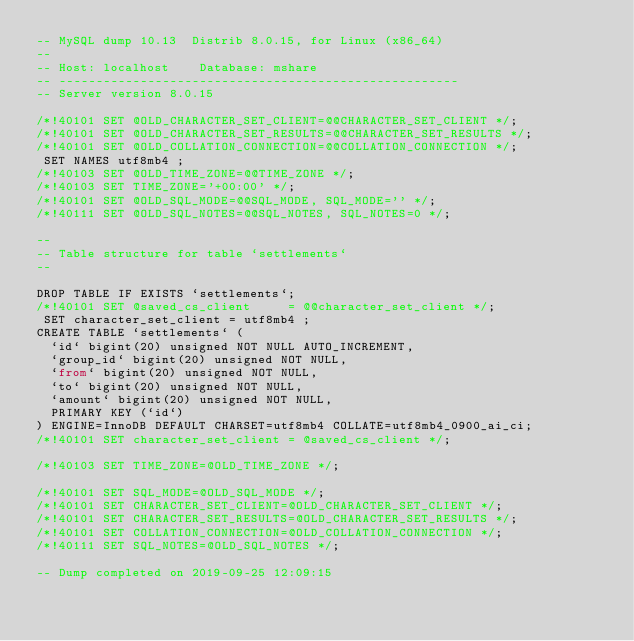Convert code to text. <code><loc_0><loc_0><loc_500><loc_500><_SQL_>-- MySQL dump 10.13  Distrib 8.0.15, for Linux (x86_64)
--
-- Host: localhost    Database: mshare
-- ------------------------------------------------------
-- Server version	8.0.15

/*!40101 SET @OLD_CHARACTER_SET_CLIENT=@@CHARACTER_SET_CLIENT */;
/*!40101 SET @OLD_CHARACTER_SET_RESULTS=@@CHARACTER_SET_RESULTS */;
/*!40101 SET @OLD_COLLATION_CONNECTION=@@COLLATION_CONNECTION */;
 SET NAMES utf8mb4 ;
/*!40103 SET @OLD_TIME_ZONE=@@TIME_ZONE */;
/*!40103 SET TIME_ZONE='+00:00' */;
/*!40101 SET @OLD_SQL_MODE=@@SQL_MODE, SQL_MODE='' */;
/*!40111 SET @OLD_SQL_NOTES=@@SQL_NOTES, SQL_NOTES=0 */;

--
-- Table structure for table `settlements`
--

DROP TABLE IF EXISTS `settlements`;
/*!40101 SET @saved_cs_client     = @@character_set_client */;
 SET character_set_client = utf8mb4 ;
CREATE TABLE `settlements` (
  `id` bigint(20) unsigned NOT NULL AUTO_INCREMENT,
  `group_id` bigint(20) unsigned NOT NULL,
  `from` bigint(20) unsigned NOT NULL,
  `to` bigint(20) unsigned NOT NULL,
  `amount` bigint(20) unsigned NOT NULL,
  PRIMARY KEY (`id`)
) ENGINE=InnoDB DEFAULT CHARSET=utf8mb4 COLLATE=utf8mb4_0900_ai_ci;
/*!40101 SET character_set_client = @saved_cs_client */;

/*!40103 SET TIME_ZONE=@OLD_TIME_ZONE */;

/*!40101 SET SQL_MODE=@OLD_SQL_MODE */;
/*!40101 SET CHARACTER_SET_CLIENT=@OLD_CHARACTER_SET_CLIENT */;
/*!40101 SET CHARACTER_SET_RESULTS=@OLD_CHARACTER_SET_RESULTS */;
/*!40101 SET COLLATION_CONNECTION=@OLD_COLLATION_CONNECTION */;
/*!40111 SET SQL_NOTES=@OLD_SQL_NOTES */;

-- Dump completed on 2019-09-25 12:09:15
</code> 